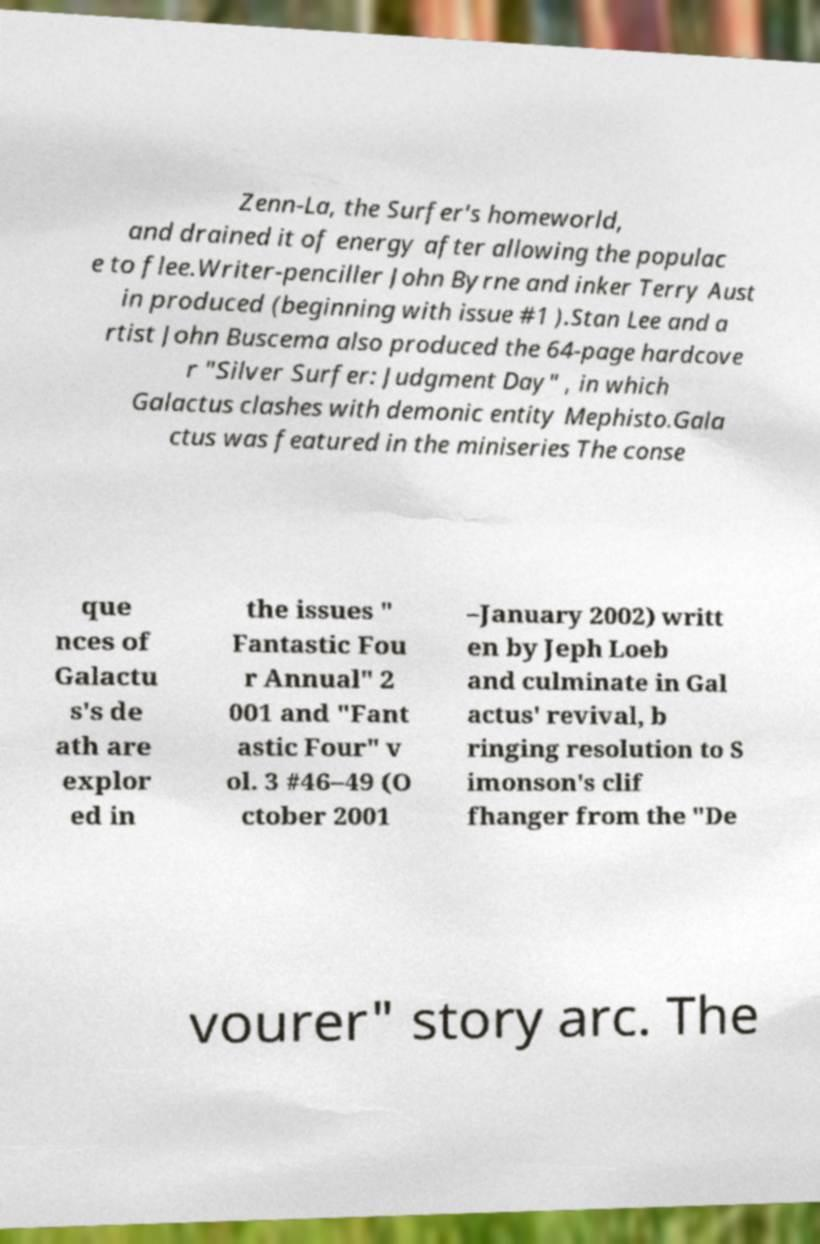What messages or text are displayed in this image? I need them in a readable, typed format. Zenn-La, the Surfer's homeworld, and drained it of energy after allowing the populac e to flee.Writer-penciller John Byrne and inker Terry Aust in produced (beginning with issue #1 ).Stan Lee and a rtist John Buscema also produced the 64-page hardcove r "Silver Surfer: Judgment Day" , in which Galactus clashes with demonic entity Mephisto.Gala ctus was featured in the miniseries The conse que nces of Galactu s's de ath are explor ed in the issues " Fantastic Fou r Annual" 2 001 and "Fant astic Four" v ol. 3 #46–49 (O ctober 2001 –January 2002) writt en by Jeph Loeb and culminate in Gal actus' revival, b ringing resolution to S imonson's clif fhanger from the "De vourer" story arc. The 